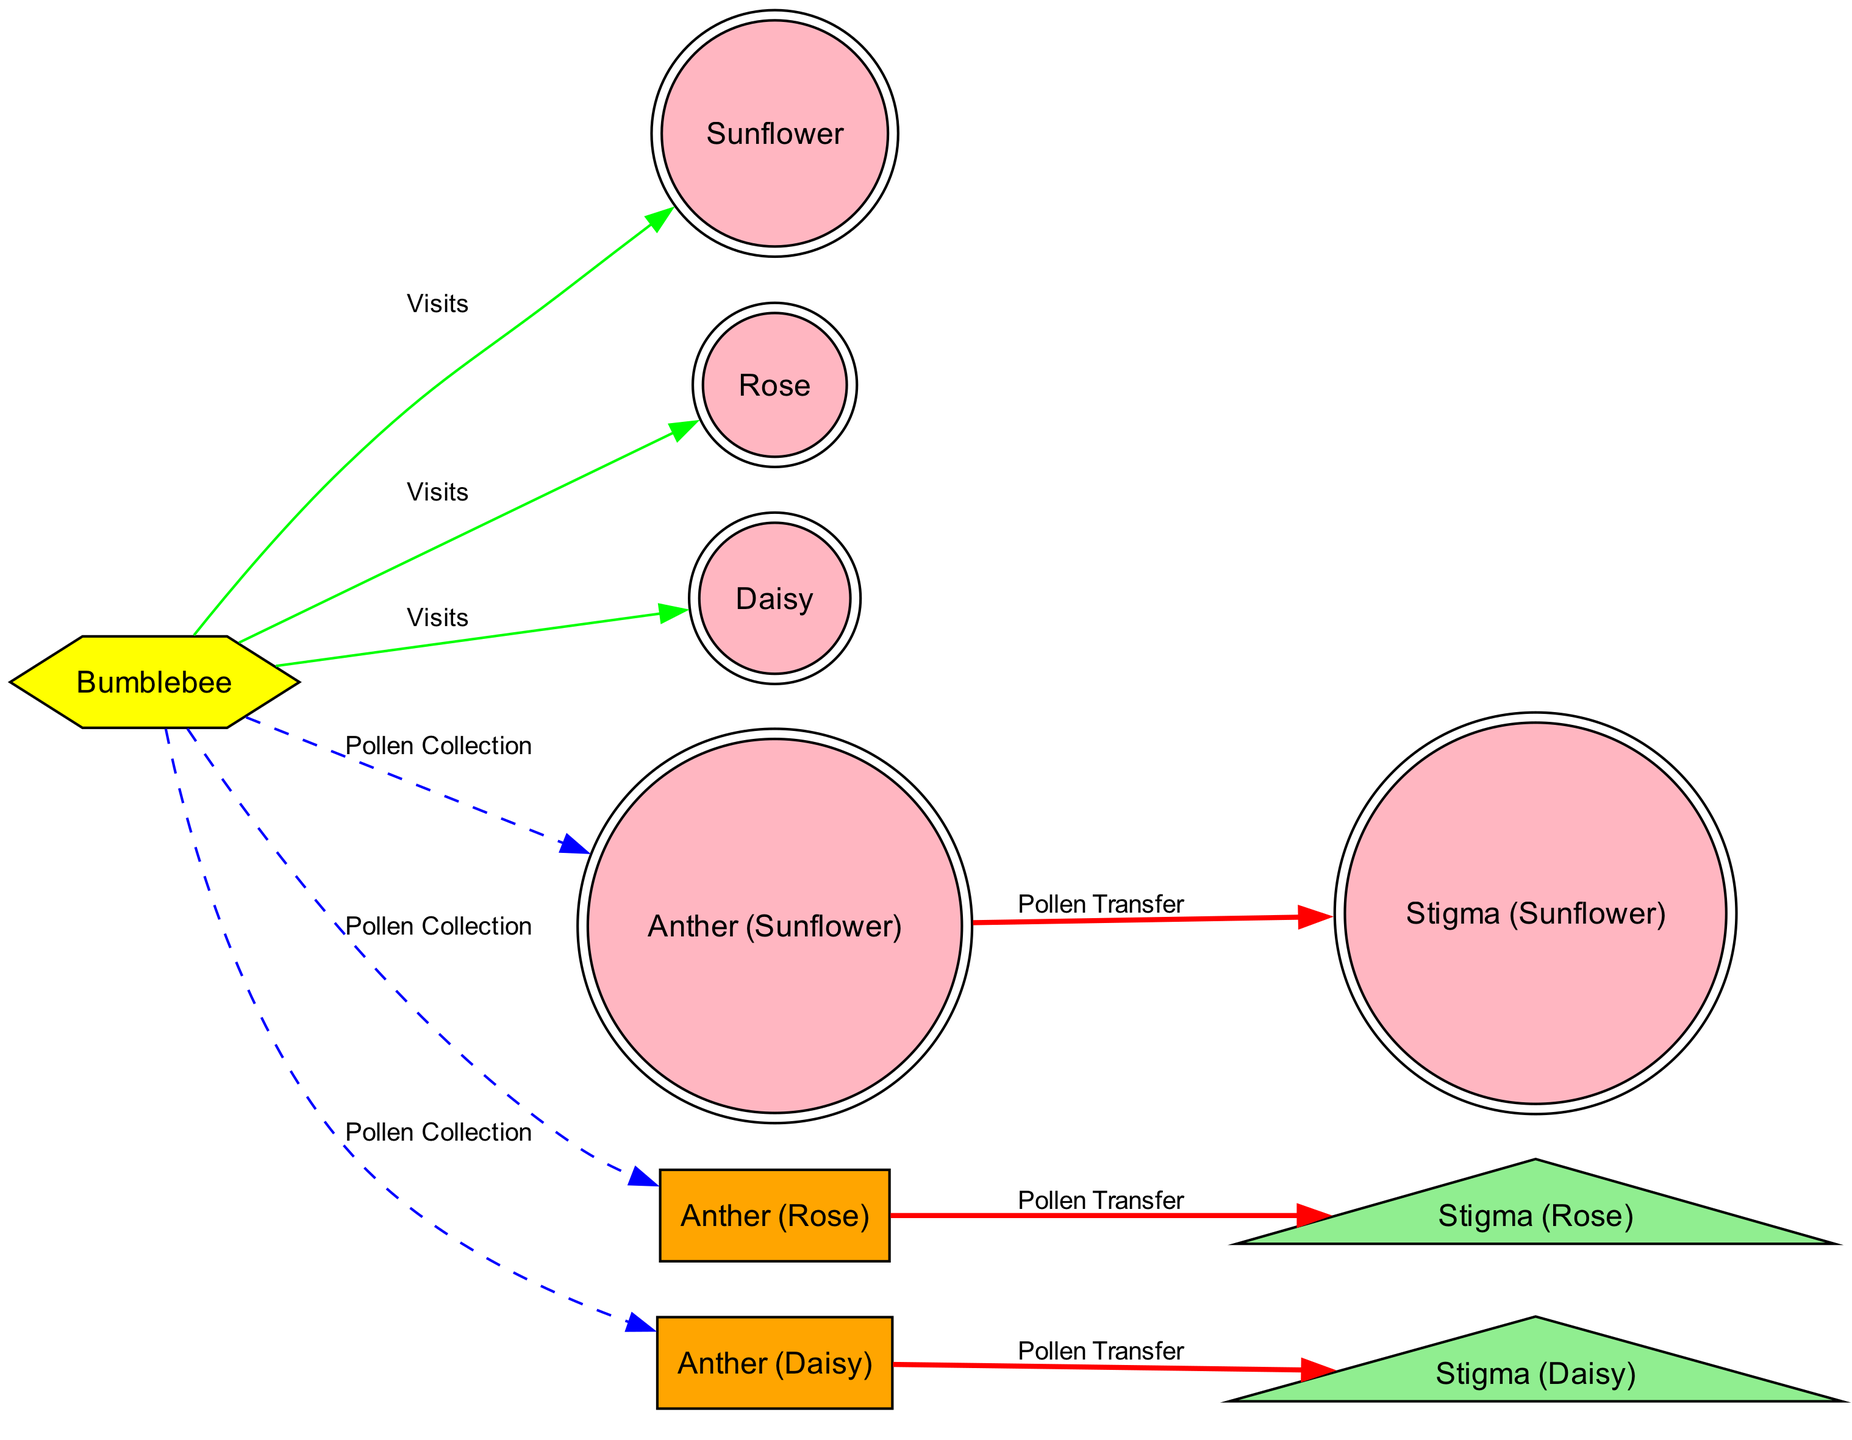What type of bee is shown in the diagram? The diagram features a "Bumblebee" node, indicating the type of bee involved in the pollination process.
Answer: Bumblebee How many flower species are represented in the diagram? The diagram lists three flower species: Sunflower, Rose, and Daisy, which can be verified by counting the respective flower nodes.
Answer: 3 What is the color of the stigma for the Sunflower? The stigma of the Sunflower is represented in green within a triangle shape, distinguishing it from other elements in the diagram.
Answer: Light green How many pollen collection actions are illustrated? The diagram displays three edges labeled "Pollen Collection" that connect the bumblebee to each type of anther, indicating the actions completed.
Answer: 3 Which flower's stigma does the anther transfer pollen to? The "Anther (Sunflower)" connects to "Stigma (Sunflower)" with an edge labeled "Pollen Transfer," showing the direct interaction involved in the process.
Answer: Stigma (Sunflower) What color is used for the pollen transfer edges? The edges labeled "Pollen Transfer" are configured with a red color and bold style, indicating their importance in the diagram.
Answer: Red What is the relationship between the bumblebee and the Rose flower? The bumblebee visits the Rose flower, denoted by an edge labeled "Visits" connecting them, showing the direct interaction in the pollination process.
Answer: Visits How many total edges are shown in the diagram? By counting all the connections (both pollen collection and transfer as well as visits), there are a total of six edges displayed in the diagram.
Answer: 9 Which two nodes are directly connected by a dashed line? The bumblebee is connected to each anther (Sunflower, Rose, Daisy) with dashed lines, depicting the process of pollen collection through those nodes.
Answer: Pollen Collection 